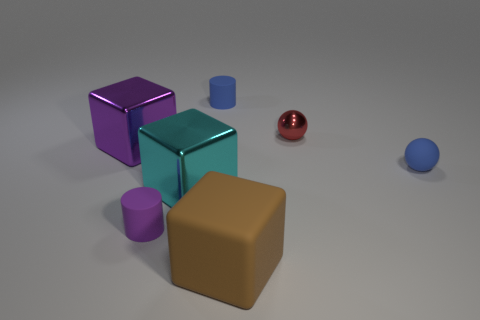Add 1 big purple blocks. How many objects exist? 8 Subtract all spheres. How many objects are left? 5 Subtract 0 purple balls. How many objects are left? 7 Subtract all large brown rubber cubes. Subtract all cubes. How many objects are left? 3 Add 3 red things. How many red things are left? 4 Add 4 big purple things. How many big purple things exist? 5 